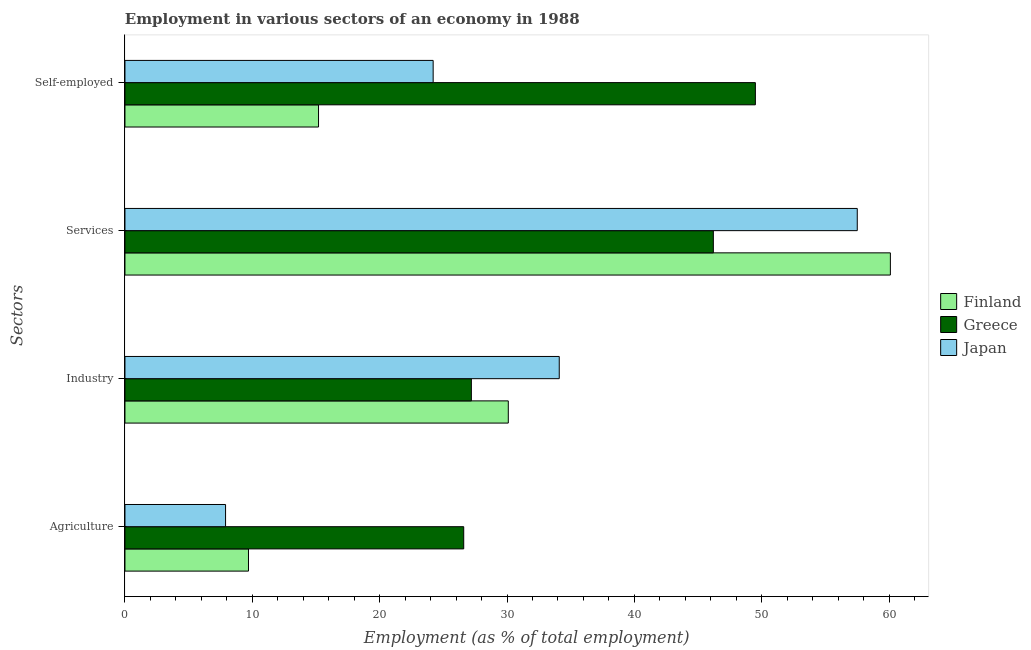How many groups of bars are there?
Keep it short and to the point. 4. Are the number of bars on each tick of the Y-axis equal?
Provide a short and direct response. Yes. How many bars are there on the 1st tick from the bottom?
Provide a succinct answer. 3. What is the label of the 1st group of bars from the top?
Make the answer very short. Self-employed. What is the percentage of workers in industry in Greece?
Give a very brief answer. 27.2. Across all countries, what is the maximum percentage of self employed workers?
Ensure brevity in your answer.  49.5. Across all countries, what is the minimum percentage of workers in industry?
Make the answer very short. 27.2. What is the total percentage of workers in services in the graph?
Your answer should be compact. 163.8. What is the difference between the percentage of workers in industry in Japan and that in Finland?
Offer a terse response. 4. What is the difference between the percentage of workers in services in Japan and the percentage of workers in industry in Greece?
Make the answer very short. 30.3. What is the average percentage of workers in services per country?
Provide a short and direct response. 54.6. What is the difference between the percentage of workers in services and percentage of workers in agriculture in Finland?
Provide a succinct answer. 50.4. What is the ratio of the percentage of workers in services in Greece to that in Japan?
Keep it short and to the point. 0.8. What is the difference between the highest and the second highest percentage of workers in agriculture?
Keep it short and to the point. 16.9. What is the difference between the highest and the lowest percentage of self employed workers?
Provide a short and direct response. 34.3. In how many countries, is the percentage of workers in agriculture greater than the average percentage of workers in agriculture taken over all countries?
Give a very brief answer. 1. What does the 3rd bar from the top in Industry represents?
Offer a very short reply. Finland. How many bars are there?
Keep it short and to the point. 12. Are all the bars in the graph horizontal?
Make the answer very short. Yes. What is the difference between two consecutive major ticks on the X-axis?
Your response must be concise. 10. Does the graph contain grids?
Offer a terse response. No. Where does the legend appear in the graph?
Your answer should be very brief. Center right. How many legend labels are there?
Keep it short and to the point. 3. What is the title of the graph?
Give a very brief answer. Employment in various sectors of an economy in 1988. What is the label or title of the X-axis?
Provide a short and direct response. Employment (as % of total employment). What is the label or title of the Y-axis?
Offer a very short reply. Sectors. What is the Employment (as % of total employment) in Finland in Agriculture?
Ensure brevity in your answer.  9.7. What is the Employment (as % of total employment) of Greece in Agriculture?
Your answer should be compact. 26.6. What is the Employment (as % of total employment) in Japan in Agriculture?
Offer a very short reply. 7.9. What is the Employment (as % of total employment) of Finland in Industry?
Your answer should be very brief. 30.1. What is the Employment (as % of total employment) of Greece in Industry?
Give a very brief answer. 27.2. What is the Employment (as % of total employment) of Japan in Industry?
Your response must be concise. 34.1. What is the Employment (as % of total employment) of Finland in Services?
Provide a succinct answer. 60.1. What is the Employment (as % of total employment) in Greece in Services?
Your answer should be compact. 46.2. What is the Employment (as % of total employment) in Japan in Services?
Your answer should be very brief. 57.5. What is the Employment (as % of total employment) in Finland in Self-employed?
Provide a succinct answer. 15.2. What is the Employment (as % of total employment) of Greece in Self-employed?
Provide a short and direct response. 49.5. What is the Employment (as % of total employment) of Japan in Self-employed?
Your response must be concise. 24.2. Across all Sectors, what is the maximum Employment (as % of total employment) of Finland?
Ensure brevity in your answer.  60.1. Across all Sectors, what is the maximum Employment (as % of total employment) in Greece?
Make the answer very short. 49.5. Across all Sectors, what is the maximum Employment (as % of total employment) of Japan?
Provide a short and direct response. 57.5. Across all Sectors, what is the minimum Employment (as % of total employment) of Finland?
Provide a short and direct response. 9.7. Across all Sectors, what is the minimum Employment (as % of total employment) of Greece?
Your response must be concise. 26.6. Across all Sectors, what is the minimum Employment (as % of total employment) of Japan?
Your response must be concise. 7.9. What is the total Employment (as % of total employment) of Finland in the graph?
Your answer should be compact. 115.1. What is the total Employment (as % of total employment) in Greece in the graph?
Offer a very short reply. 149.5. What is the total Employment (as % of total employment) in Japan in the graph?
Your answer should be very brief. 123.7. What is the difference between the Employment (as % of total employment) in Finland in Agriculture and that in Industry?
Offer a very short reply. -20.4. What is the difference between the Employment (as % of total employment) in Japan in Agriculture and that in Industry?
Provide a succinct answer. -26.2. What is the difference between the Employment (as % of total employment) in Finland in Agriculture and that in Services?
Offer a terse response. -50.4. What is the difference between the Employment (as % of total employment) of Greece in Agriculture and that in Services?
Your response must be concise. -19.6. What is the difference between the Employment (as % of total employment) in Japan in Agriculture and that in Services?
Give a very brief answer. -49.6. What is the difference between the Employment (as % of total employment) of Greece in Agriculture and that in Self-employed?
Your answer should be compact. -22.9. What is the difference between the Employment (as % of total employment) of Japan in Agriculture and that in Self-employed?
Your answer should be very brief. -16.3. What is the difference between the Employment (as % of total employment) of Japan in Industry and that in Services?
Ensure brevity in your answer.  -23.4. What is the difference between the Employment (as % of total employment) of Greece in Industry and that in Self-employed?
Make the answer very short. -22.3. What is the difference between the Employment (as % of total employment) in Japan in Industry and that in Self-employed?
Offer a very short reply. 9.9. What is the difference between the Employment (as % of total employment) of Finland in Services and that in Self-employed?
Your answer should be compact. 44.9. What is the difference between the Employment (as % of total employment) of Japan in Services and that in Self-employed?
Provide a succinct answer. 33.3. What is the difference between the Employment (as % of total employment) of Finland in Agriculture and the Employment (as % of total employment) of Greece in Industry?
Give a very brief answer. -17.5. What is the difference between the Employment (as % of total employment) in Finland in Agriculture and the Employment (as % of total employment) in Japan in Industry?
Make the answer very short. -24.4. What is the difference between the Employment (as % of total employment) in Finland in Agriculture and the Employment (as % of total employment) in Greece in Services?
Provide a succinct answer. -36.5. What is the difference between the Employment (as % of total employment) in Finland in Agriculture and the Employment (as % of total employment) in Japan in Services?
Ensure brevity in your answer.  -47.8. What is the difference between the Employment (as % of total employment) in Greece in Agriculture and the Employment (as % of total employment) in Japan in Services?
Keep it short and to the point. -30.9. What is the difference between the Employment (as % of total employment) of Finland in Agriculture and the Employment (as % of total employment) of Greece in Self-employed?
Provide a short and direct response. -39.8. What is the difference between the Employment (as % of total employment) in Finland in Agriculture and the Employment (as % of total employment) in Japan in Self-employed?
Offer a very short reply. -14.5. What is the difference between the Employment (as % of total employment) of Greece in Agriculture and the Employment (as % of total employment) of Japan in Self-employed?
Your answer should be compact. 2.4. What is the difference between the Employment (as % of total employment) of Finland in Industry and the Employment (as % of total employment) of Greece in Services?
Your answer should be very brief. -16.1. What is the difference between the Employment (as % of total employment) of Finland in Industry and the Employment (as % of total employment) of Japan in Services?
Provide a succinct answer. -27.4. What is the difference between the Employment (as % of total employment) in Greece in Industry and the Employment (as % of total employment) in Japan in Services?
Offer a terse response. -30.3. What is the difference between the Employment (as % of total employment) of Finland in Industry and the Employment (as % of total employment) of Greece in Self-employed?
Offer a very short reply. -19.4. What is the difference between the Employment (as % of total employment) in Greece in Industry and the Employment (as % of total employment) in Japan in Self-employed?
Offer a very short reply. 3. What is the difference between the Employment (as % of total employment) of Finland in Services and the Employment (as % of total employment) of Japan in Self-employed?
Your answer should be compact. 35.9. What is the difference between the Employment (as % of total employment) of Greece in Services and the Employment (as % of total employment) of Japan in Self-employed?
Provide a succinct answer. 22. What is the average Employment (as % of total employment) in Finland per Sectors?
Offer a very short reply. 28.77. What is the average Employment (as % of total employment) of Greece per Sectors?
Give a very brief answer. 37.38. What is the average Employment (as % of total employment) in Japan per Sectors?
Offer a terse response. 30.93. What is the difference between the Employment (as % of total employment) in Finland and Employment (as % of total employment) in Greece in Agriculture?
Ensure brevity in your answer.  -16.9. What is the difference between the Employment (as % of total employment) in Greece and Employment (as % of total employment) in Japan in Agriculture?
Offer a terse response. 18.7. What is the difference between the Employment (as % of total employment) in Finland and Employment (as % of total employment) in Greece in Industry?
Keep it short and to the point. 2.9. What is the difference between the Employment (as % of total employment) in Finland and Employment (as % of total employment) in Japan in Services?
Provide a short and direct response. 2.6. What is the difference between the Employment (as % of total employment) in Greece and Employment (as % of total employment) in Japan in Services?
Keep it short and to the point. -11.3. What is the difference between the Employment (as % of total employment) in Finland and Employment (as % of total employment) in Greece in Self-employed?
Ensure brevity in your answer.  -34.3. What is the difference between the Employment (as % of total employment) in Finland and Employment (as % of total employment) in Japan in Self-employed?
Your response must be concise. -9. What is the difference between the Employment (as % of total employment) of Greece and Employment (as % of total employment) of Japan in Self-employed?
Ensure brevity in your answer.  25.3. What is the ratio of the Employment (as % of total employment) of Finland in Agriculture to that in Industry?
Give a very brief answer. 0.32. What is the ratio of the Employment (as % of total employment) of Greece in Agriculture to that in Industry?
Your answer should be compact. 0.98. What is the ratio of the Employment (as % of total employment) in Japan in Agriculture to that in Industry?
Your response must be concise. 0.23. What is the ratio of the Employment (as % of total employment) in Finland in Agriculture to that in Services?
Provide a short and direct response. 0.16. What is the ratio of the Employment (as % of total employment) of Greece in Agriculture to that in Services?
Keep it short and to the point. 0.58. What is the ratio of the Employment (as % of total employment) in Japan in Agriculture to that in Services?
Provide a succinct answer. 0.14. What is the ratio of the Employment (as % of total employment) of Finland in Agriculture to that in Self-employed?
Make the answer very short. 0.64. What is the ratio of the Employment (as % of total employment) in Greece in Agriculture to that in Self-employed?
Provide a short and direct response. 0.54. What is the ratio of the Employment (as % of total employment) of Japan in Agriculture to that in Self-employed?
Your response must be concise. 0.33. What is the ratio of the Employment (as % of total employment) of Finland in Industry to that in Services?
Provide a short and direct response. 0.5. What is the ratio of the Employment (as % of total employment) of Greece in Industry to that in Services?
Provide a succinct answer. 0.59. What is the ratio of the Employment (as % of total employment) of Japan in Industry to that in Services?
Your response must be concise. 0.59. What is the ratio of the Employment (as % of total employment) in Finland in Industry to that in Self-employed?
Give a very brief answer. 1.98. What is the ratio of the Employment (as % of total employment) of Greece in Industry to that in Self-employed?
Provide a succinct answer. 0.55. What is the ratio of the Employment (as % of total employment) of Japan in Industry to that in Self-employed?
Provide a succinct answer. 1.41. What is the ratio of the Employment (as % of total employment) in Finland in Services to that in Self-employed?
Offer a terse response. 3.95. What is the ratio of the Employment (as % of total employment) of Japan in Services to that in Self-employed?
Your response must be concise. 2.38. What is the difference between the highest and the second highest Employment (as % of total employment) of Japan?
Your answer should be compact. 23.4. What is the difference between the highest and the lowest Employment (as % of total employment) in Finland?
Make the answer very short. 50.4. What is the difference between the highest and the lowest Employment (as % of total employment) in Greece?
Your answer should be very brief. 22.9. What is the difference between the highest and the lowest Employment (as % of total employment) in Japan?
Make the answer very short. 49.6. 